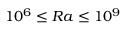Convert formula to latex. <formula><loc_0><loc_0><loc_500><loc_500>1 0 ^ { 6 } \leq R a \leq 1 0 ^ { 9 }</formula> 